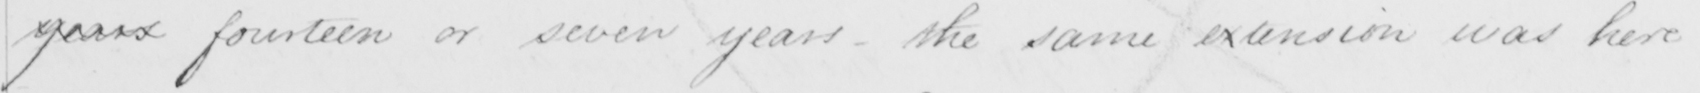What text is written in this handwritten line? years fourteen or seven years - the same extension was here 